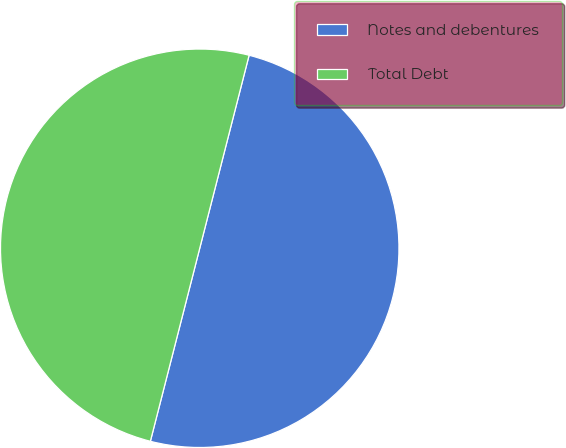Convert chart to OTSL. <chart><loc_0><loc_0><loc_500><loc_500><pie_chart><fcel>Notes and debentures<fcel>Total Debt<nl><fcel>50.0%<fcel>50.0%<nl></chart> 